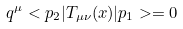Convert formula to latex. <formula><loc_0><loc_0><loc_500><loc_500>q ^ { \mu } < p _ { 2 } | T _ { \mu \nu } ( x ) | p _ { 1 } > = 0</formula> 